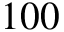Convert formula to latex. <formula><loc_0><loc_0><loc_500><loc_500>1 0 0</formula> 